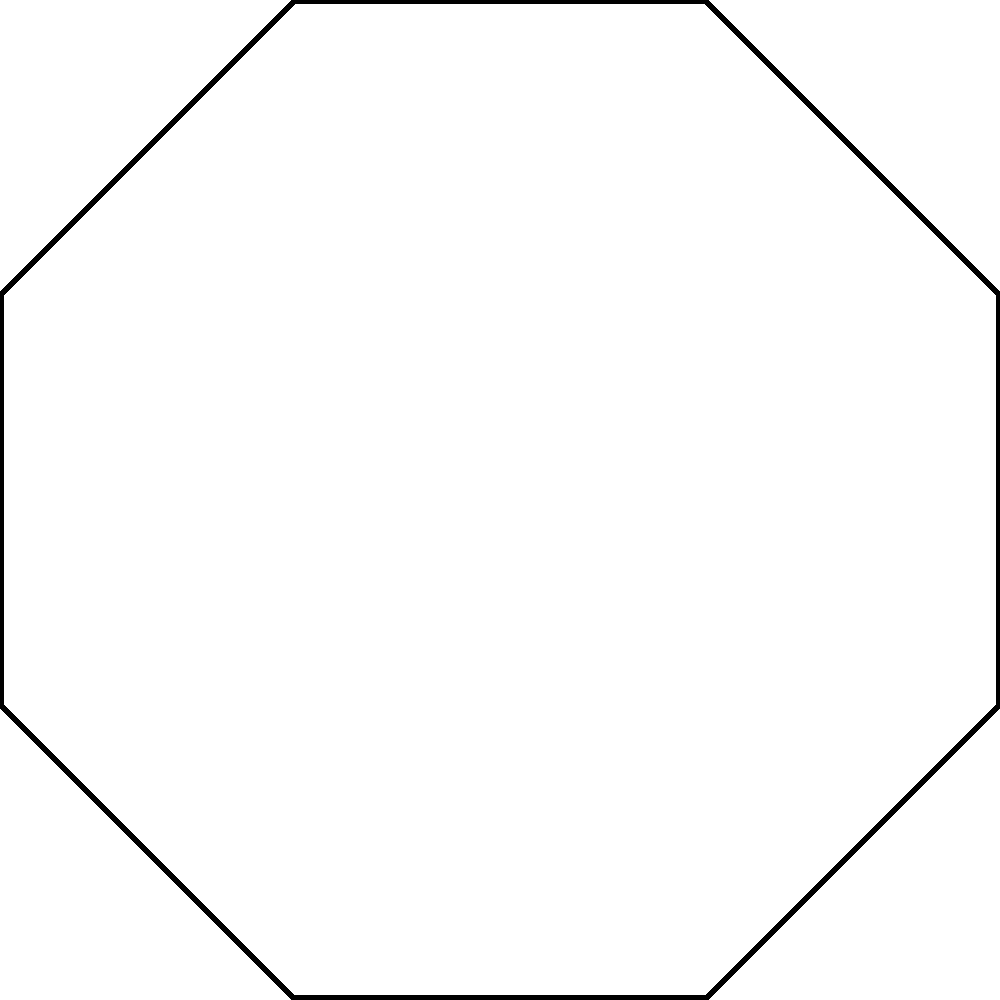In this traditional Middle Eastern pattern, how many rotational symmetries does the entire figure possess? To determine the number of rotational symmetries in this pattern, we need to follow these steps:

1. Observe the overall structure of the pattern. It consists of overlapping octagons (8-sided polygons) arranged in a circular formation.

2. Count the number of distinct positions where the pattern looks exactly the same after rotation. In this case:
   a) The pattern looks the same after every 45° rotation.
   b) A full rotation is 360°.

3. Calculate the number of rotational symmetries:
   $$\text{Number of rotational symmetries} = \frac{360°}{\text{Angle between symmetries}}$$
   $$= \frac{360°}{45°} = 8$$

4. Verify visually:
   - 0° (original position)
   - 45°
   - 90°
   - 135°
   - 180°
   - 225°
   - 270°
   - 315°

Each of these rotations brings the pattern back to a position indistinguishable from the original.

5. Note that the red octagon, which is rotated by 22.5°, helps to highlight that there are indeed 8 distinct positions, as it appears in a different orientation in each symmetry.

This type of symmetry is common in Islamic geometric patterns, reflecting the importance of balance and harmony in Middle Eastern art and architecture.
Answer: 8 